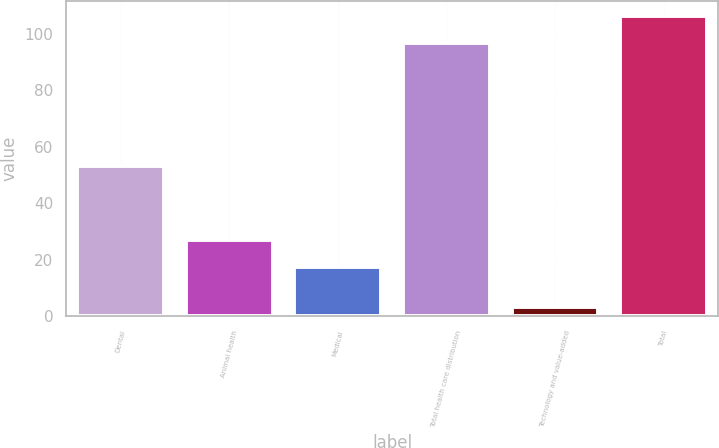<chart> <loc_0><loc_0><loc_500><loc_500><bar_chart><fcel>Dental<fcel>Animal health<fcel>Medical<fcel>Total health care distribution<fcel>Technology and value-added<fcel>Total<nl><fcel>53.4<fcel>27.08<fcel>17.4<fcel>96.8<fcel>3.2<fcel>106.48<nl></chart> 